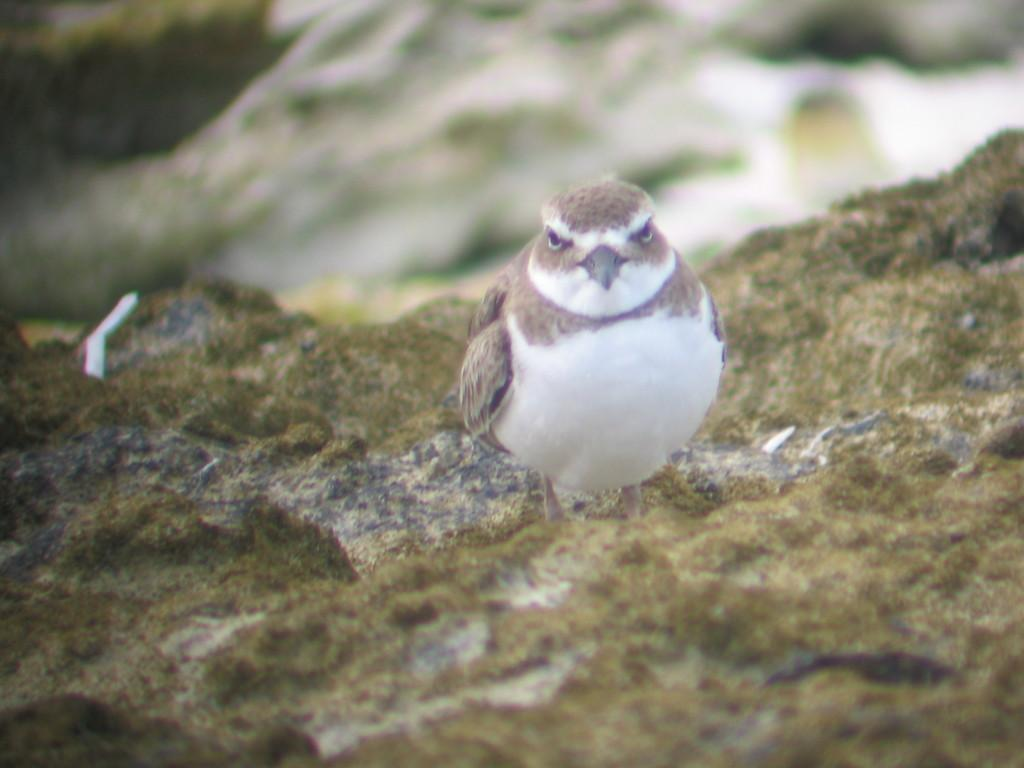What is the main subject in the center of the image? There is a bird in the center of the image. What can be seen at the bottom of the image? There are rocks at the bottom of the image. How would you describe the background of the image? The background of the image is blurry. What type of meat is hanging from the bird in the image? There is no meat present in the image; it features of the bird can be seen, but no meat is attached to it. 